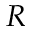Convert formula to latex. <formula><loc_0><loc_0><loc_500><loc_500>R</formula> 